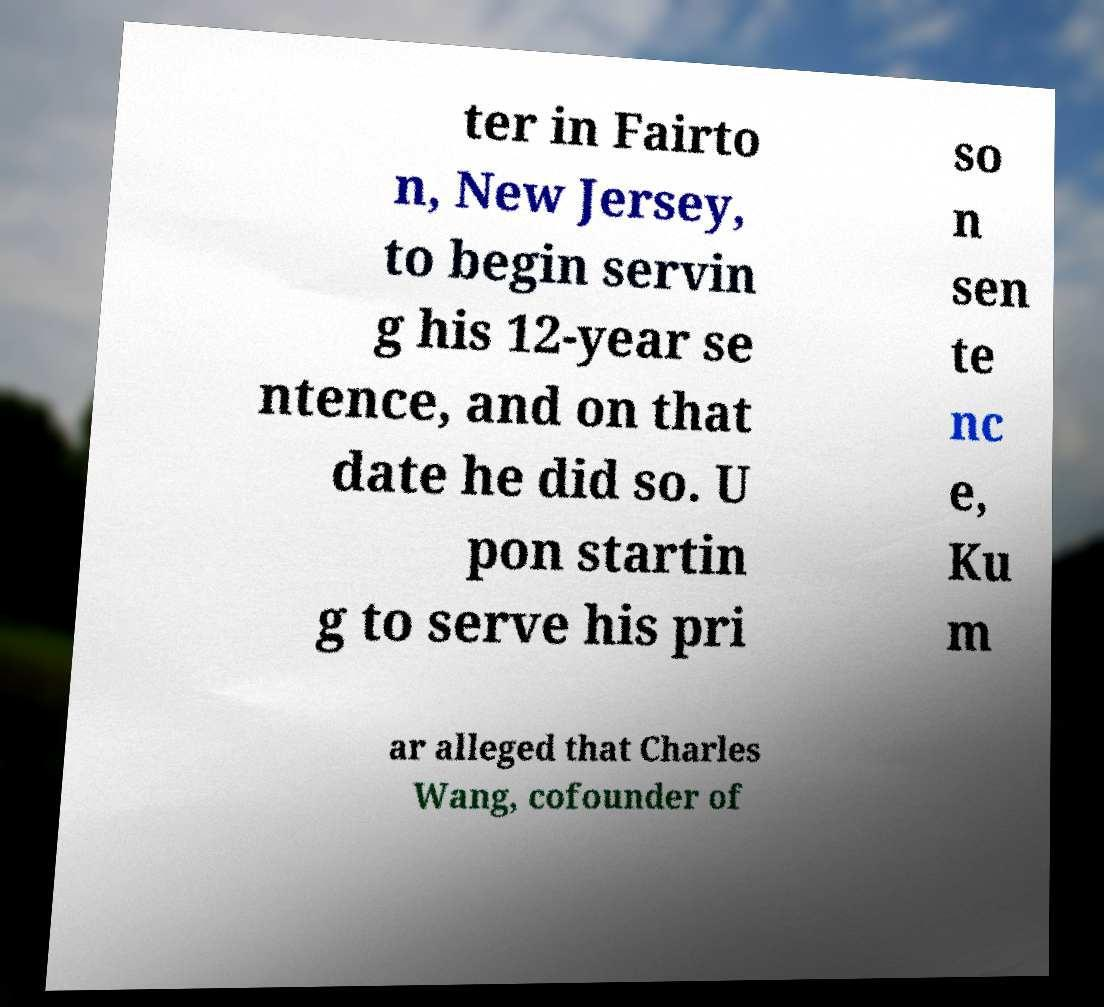Please read and relay the text visible in this image. What does it say? ter in Fairto n, New Jersey, to begin servin g his 12-year se ntence, and on that date he did so. U pon startin g to serve his pri so n sen te nc e, Ku m ar alleged that Charles Wang, cofounder of 